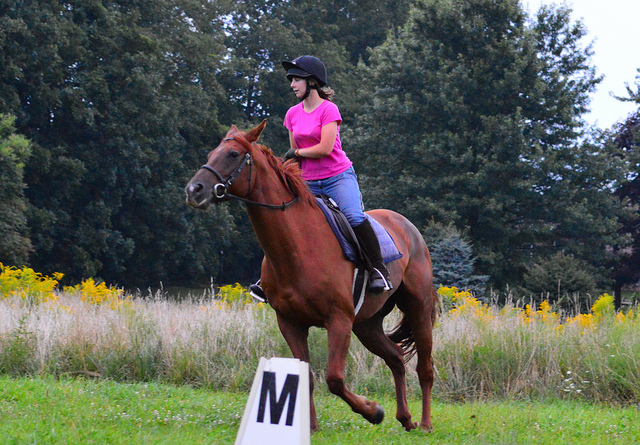Please transcribe the text in this image. M 